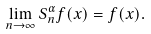<formula> <loc_0><loc_0><loc_500><loc_500>\lim _ { n \rightarrow \infty } S ^ { \alpha } _ { n } f ( x ) = f ( x ) .</formula> 